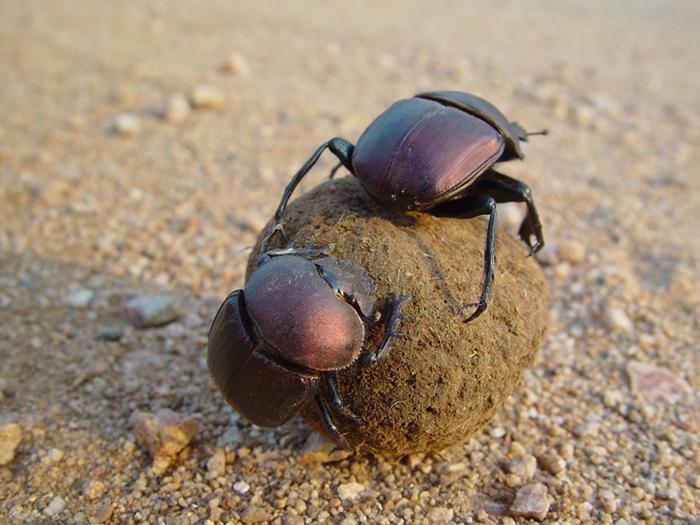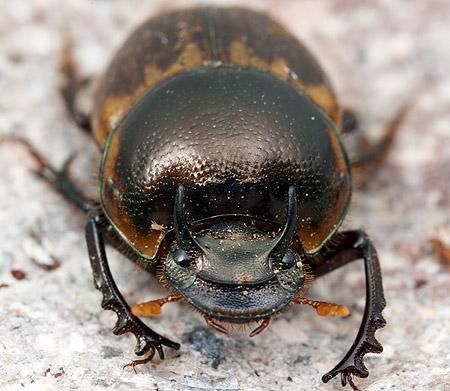The first image is the image on the left, the second image is the image on the right. Examine the images to the left and right. Is the description "Two beetles climb on a clod of dirt in the image on the left." accurate? Answer yes or no. Yes. The first image is the image on the left, the second image is the image on the right. Evaluate the accuracy of this statement regarding the images: "A beetle with a shiny textured back is alone in an image without a dung ball shape.". Is it true? Answer yes or no. Yes. 